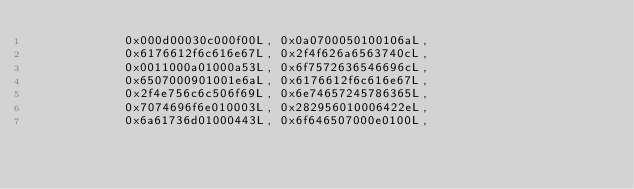<code> <loc_0><loc_0><loc_500><loc_500><_Java_>            0x000d00030c000f00L, 0x0a0700050100106aL,
            0x6176612f6c616e67L, 0x2f4f626a6563740cL,
            0x0011000a01000a53L, 0x6f7572636546696cL,
            0x6507000901001e6aL, 0x6176612f6c616e67L,
            0x2f4e756c6c506f69L, 0x6e74657245786365L,
            0x7074696f6e010003L, 0x282956010006422eL,
            0x6a61736d01000443L, 0x6f646507000e0100L,</code> 